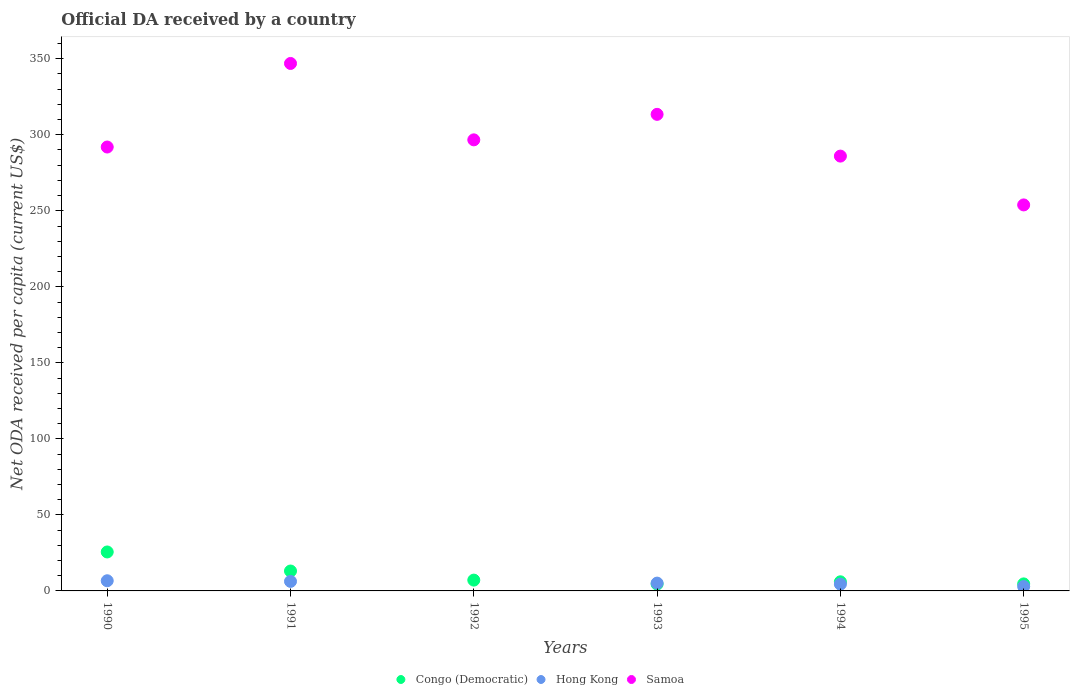Is the number of dotlines equal to the number of legend labels?
Offer a terse response. No. What is the ODA received in in Hong Kong in 1995?
Ensure brevity in your answer.  2.88. Across all years, what is the maximum ODA received in in Congo (Democratic)?
Make the answer very short. 25.62. Across all years, what is the minimum ODA received in in Congo (Democratic)?
Give a very brief answer. 4.52. What is the total ODA received in in Hong Kong in the graph?
Provide a short and direct response. 25.42. What is the difference between the ODA received in in Congo (Democratic) in 1990 and that in 1993?
Offer a terse response. 21.1. What is the difference between the ODA received in in Congo (Democratic) in 1991 and the ODA received in in Hong Kong in 1995?
Your answer should be very brief. 10.21. What is the average ODA received in in Samoa per year?
Provide a succinct answer. 298.14. In the year 1990, what is the difference between the ODA received in in Congo (Democratic) and ODA received in in Samoa?
Offer a terse response. -266.34. In how many years, is the ODA received in in Samoa greater than 200 US$?
Your answer should be very brief. 6. What is the ratio of the ODA received in in Congo (Democratic) in 1990 to that in 1994?
Provide a short and direct response. 4.27. Is the difference between the ODA received in in Congo (Democratic) in 1992 and 1994 greater than the difference between the ODA received in in Samoa in 1992 and 1994?
Offer a very short reply. No. What is the difference between the highest and the second highest ODA received in in Congo (Democratic)?
Provide a succinct answer. 12.53. What is the difference between the highest and the lowest ODA received in in Congo (Democratic)?
Provide a short and direct response. 21.1. Is the sum of the ODA received in in Samoa in 1992 and 1993 greater than the maximum ODA received in in Hong Kong across all years?
Your response must be concise. Yes. Does the ODA received in in Congo (Democratic) monotonically increase over the years?
Your response must be concise. No. Is the ODA received in in Congo (Democratic) strictly less than the ODA received in in Samoa over the years?
Offer a very short reply. Yes. How many dotlines are there?
Give a very brief answer. 3. What is the difference between two consecutive major ticks on the Y-axis?
Your answer should be compact. 50. Are the values on the major ticks of Y-axis written in scientific E-notation?
Give a very brief answer. No. Does the graph contain any zero values?
Provide a short and direct response. Yes. What is the title of the graph?
Ensure brevity in your answer.  Official DA received by a country. What is the label or title of the X-axis?
Provide a succinct answer. Years. What is the label or title of the Y-axis?
Your answer should be very brief. Net ODA received per capita (current US$). What is the Net ODA received per capita (current US$) of Congo (Democratic) in 1990?
Your answer should be compact. 25.62. What is the Net ODA received per capita (current US$) of Hong Kong in 1990?
Offer a terse response. 6.69. What is the Net ODA received per capita (current US$) of Samoa in 1990?
Offer a terse response. 291.96. What is the Net ODA received per capita (current US$) of Congo (Democratic) in 1991?
Your answer should be compact. 13.09. What is the Net ODA received per capita (current US$) in Hong Kong in 1991?
Offer a terse response. 6.27. What is the Net ODA received per capita (current US$) of Samoa in 1991?
Provide a succinct answer. 346.92. What is the Net ODA received per capita (current US$) in Congo (Democratic) in 1992?
Ensure brevity in your answer.  7.11. What is the Net ODA received per capita (current US$) of Samoa in 1992?
Provide a succinct answer. 296.68. What is the Net ODA received per capita (current US$) of Congo (Democratic) in 1993?
Provide a short and direct response. 4.52. What is the Net ODA received per capita (current US$) of Hong Kong in 1993?
Ensure brevity in your answer.  5.13. What is the Net ODA received per capita (current US$) of Samoa in 1993?
Offer a very short reply. 313.45. What is the Net ODA received per capita (current US$) of Congo (Democratic) in 1994?
Make the answer very short. 6. What is the Net ODA received per capita (current US$) of Hong Kong in 1994?
Offer a terse response. 4.45. What is the Net ODA received per capita (current US$) of Samoa in 1994?
Make the answer very short. 285.98. What is the Net ODA received per capita (current US$) in Congo (Democratic) in 1995?
Your answer should be very brief. 4.62. What is the Net ODA received per capita (current US$) of Hong Kong in 1995?
Provide a succinct answer. 2.88. What is the Net ODA received per capita (current US$) of Samoa in 1995?
Your response must be concise. 253.88. Across all years, what is the maximum Net ODA received per capita (current US$) of Congo (Democratic)?
Keep it short and to the point. 25.62. Across all years, what is the maximum Net ODA received per capita (current US$) of Hong Kong?
Give a very brief answer. 6.69. Across all years, what is the maximum Net ODA received per capita (current US$) of Samoa?
Your response must be concise. 346.92. Across all years, what is the minimum Net ODA received per capita (current US$) of Congo (Democratic)?
Your answer should be compact. 4.52. Across all years, what is the minimum Net ODA received per capita (current US$) of Hong Kong?
Keep it short and to the point. 0. Across all years, what is the minimum Net ODA received per capita (current US$) in Samoa?
Your answer should be compact. 253.88. What is the total Net ODA received per capita (current US$) in Congo (Democratic) in the graph?
Provide a succinct answer. 60.96. What is the total Net ODA received per capita (current US$) of Hong Kong in the graph?
Your answer should be compact. 25.42. What is the total Net ODA received per capita (current US$) in Samoa in the graph?
Provide a succinct answer. 1788.86. What is the difference between the Net ODA received per capita (current US$) in Congo (Democratic) in 1990 and that in 1991?
Keep it short and to the point. 12.53. What is the difference between the Net ODA received per capita (current US$) in Hong Kong in 1990 and that in 1991?
Offer a terse response. 0.42. What is the difference between the Net ODA received per capita (current US$) in Samoa in 1990 and that in 1991?
Offer a very short reply. -54.96. What is the difference between the Net ODA received per capita (current US$) in Congo (Democratic) in 1990 and that in 1992?
Provide a succinct answer. 18.51. What is the difference between the Net ODA received per capita (current US$) of Samoa in 1990 and that in 1992?
Provide a succinct answer. -4.72. What is the difference between the Net ODA received per capita (current US$) in Congo (Democratic) in 1990 and that in 1993?
Keep it short and to the point. 21.1. What is the difference between the Net ODA received per capita (current US$) in Hong Kong in 1990 and that in 1993?
Provide a short and direct response. 1.56. What is the difference between the Net ODA received per capita (current US$) in Samoa in 1990 and that in 1993?
Keep it short and to the point. -21.49. What is the difference between the Net ODA received per capita (current US$) of Congo (Democratic) in 1990 and that in 1994?
Keep it short and to the point. 19.62. What is the difference between the Net ODA received per capita (current US$) in Hong Kong in 1990 and that in 1994?
Provide a short and direct response. 2.24. What is the difference between the Net ODA received per capita (current US$) of Samoa in 1990 and that in 1994?
Ensure brevity in your answer.  5.98. What is the difference between the Net ODA received per capita (current US$) in Congo (Democratic) in 1990 and that in 1995?
Ensure brevity in your answer.  21. What is the difference between the Net ODA received per capita (current US$) of Hong Kong in 1990 and that in 1995?
Make the answer very short. 3.81. What is the difference between the Net ODA received per capita (current US$) in Samoa in 1990 and that in 1995?
Provide a short and direct response. 38.08. What is the difference between the Net ODA received per capita (current US$) of Congo (Democratic) in 1991 and that in 1992?
Ensure brevity in your answer.  5.98. What is the difference between the Net ODA received per capita (current US$) of Samoa in 1991 and that in 1992?
Ensure brevity in your answer.  50.24. What is the difference between the Net ODA received per capita (current US$) in Congo (Democratic) in 1991 and that in 1993?
Give a very brief answer. 8.57. What is the difference between the Net ODA received per capita (current US$) of Hong Kong in 1991 and that in 1993?
Provide a short and direct response. 1.14. What is the difference between the Net ODA received per capita (current US$) in Samoa in 1991 and that in 1993?
Offer a terse response. 33.47. What is the difference between the Net ODA received per capita (current US$) of Congo (Democratic) in 1991 and that in 1994?
Offer a terse response. 7.09. What is the difference between the Net ODA received per capita (current US$) in Hong Kong in 1991 and that in 1994?
Keep it short and to the point. 1.82. What is the difference between the Net ODA received per capita (current US$) of Samoa in 1991 and that in 1994?
Your answer should be compact. 60.94. What is the difference between the Net ODA received per capita (current US$) in Congo (Democratic) in 1991 and that in 1995?
Your response must be concise. 8.47. What is the difference between the Net ODA received per capita (current US$) in Hong Kong in 1991 and that in 1995?
Provide a succinct answer. 3.39. What is the difference between the Net ODA received per capita (current US$) in Samoa in 1991 and that in 1995?
Provide a short and direct response. 93.04. What is the difference between the Net ODA received per capita (current US$) of Congo (Democratic) in 1992 and that in 1993?
Provide a short and direct response. 2.58. What is the difference between the Net ODA received per capita (current US$) in Samoa in 1992 and that in 1993?
Make the answer very short. -16.77. What is the difference between the Net ODA received per capita (current US$) of Congo (Democratic) in 1992 and that in 1994?
Your response must be concise. 1.11. What is the difference between the Net ODA received per capita (current US$) in Samoa in 1992 and that in 1994?
Keep it short and to the point. 10.69. What is the difference between the Net ODA received per capita (current US$) of Congo (Democratic) in 1992 and that in 1995?
Make the answer very short. 2.49. What is the difference between the Net ODA received per capita (current US$) of Samoa in 1992 and that in 1995?
Ensure brevity in your answer.  42.79. What is the difference between the Net ODA received per capita (current US$) of Congo (Democratic) in 1993 and that in 1994?
Ensure brevity in your answer.  -1.48. What is the difference between the Net ODA received per capita (current US$) of Hong Kong in 1993 and that in 1994?
Make the answer very short. 0.68. What is the difference between the Net ODA received per capita (current US$) in Samoa in 1993 and that in 1994?
Offer a terse response. 27.46. What is the difference between the Net ODA received per capita (current US$) of Congo (Democratic) in 1993 and that in 1995?
Your answer should be compact. -0.09. What is the difference between the Net ODA received per capita (current US$) of Hong Kong in 1993 and that in 1995?
Offer a terse response. 2.25. What is the difference between the Net ODA received per capita (current US$) in Samoa in 1993 and that in 1995?
Provide a short and direct response. 59.56. What is the difference between the Net ODA received per capita (current US$) of Congo (Democratic) in 1994 and that in 1995?
Give a very brief answer. 1.38. What is the difference between the Net ODA received per capita (current US$) in Hong Kong in 1994 and that in 1995?
Offer a very short reply. 1.57. What is the difference between the Net ODA received per capita (current US$) of Samoa in 1994 and that in 1995?
Offer a very short reply. 32.1. What is the difference between the Net ODA received per capita (current US$) of Congo (Democratic) in 1990 and the Net ODA received per capita (current US$) of Hong Kong in 1991?
Make the answer very short. 19.35. What is the difference between the Net ODA received per capita (current US$) in Congo (Democratic) in 1990 and the Net ODA received per capita (current US$) in Samoa in 1991?
Keep it short and to the point. -321.3. What is the difference between the Net ODA received per capita (current US$) of Hong Kong in 1990 and the Net ODA received per capita (current US$) of Samoa in 1991?
Offer a very short reply. -340.23. What is the difference between the Net ODA received per capita (current US$) of Congo (Democratic) in 1990 and the Net ODA received per capita (current US$) of Samoa in 1992?
Your response must be concise. -271.05. What is the difference between the Net ODA received per capita (current US$) of Hong Kong in 1990 and the Net ODA received per capita (current US$) of Samoa in 1992?
Provide a succinct answer. -289.99. What is the difference between the Net ODA received per capita (current US$) of Congo (Democratic) in 1990 and the Net ODA received per capita (current US$) of Hong Kong in 1993?
Your answer should be very brief. 20.49. What is the difference between the Net ODA received per capita (current US$) in Congo (Democratic) in 1990 and the Net ODA received per capita (current US$) in Samoa in 1993?
Make the answer very short. -287.82. What is the difference between the Net ODA received per capita (current US$) of Hong Kong in 1990 and the Net ODA received per capita (current US$) of Samoa in 1993?
Offer a very short reply. -306.76. What is the difference between the Net ODA received per capita (current US$) in Congo (Democratic) in 1990 and the Net ODA received per capita (current US$) in Hong Kong in 1994?
Your response must be concise. 21.17. What is the difference between the Net ODA received per capita (current US$) of Congo (Democratic) in 1990 and the Net ODA received per capita (current US$) of Samoa in 1994?
Offer a very short reply. -260.36. What is the difference between the Net ODA received per capita (current US$) in Hong Kong in 1990 and the Net ODA received per capita (current US$) in Samoa in 1994?
Provide a succinct answer. -279.29. What is the difference between the Net ODA received per capita (current US$) in Congo (Democratic) in 1990 and the Net ODA received per capita (current US$) in Hong Kong in 1995?
Keep it short and to the point. 22.74. What is the difference between the Net ODA received per capita (current US$) of Congo (Democratic) in 1990 and the Net ODA received per capita (current US$) of Samoa in 1995?
Ensure brevity in your answer.  -228.26. What is the difference between the Net ODA received per capita (current US$) in Hong Kong in 1990 and the Net ODA received per capita (current US$) in Samoa in 1995?
Your response must be concise. -247.19. What is the difference between the Net ODA received per capita (current US$) of Congo (Democratic) in 1991 and the Net ODA received per capita (current US$) of Samoa in 1992?
Keep it short and to the point. -283.59. What is the difference between the Net ODA received per capita (current US$) of Hong Kong in 1991 and the Net ODA received per capita (current US$) of Samoa in 1992?
Make the answer very short. -290.4. What is the difference between the Net ODA received per capita (current US$) in Congo (Democratic) in 1991 and the Net ODA received per capita (current US$) in Hong Kong in 1993?
Keep it short and to the point. 7.96. What is the difference between the Net ODA received per capita (current US$) in Congo (Democratic) in 1991 and the Net ODA received per capita (current US$) in Samoa in 1993?
Provide a short and direct response. -300.36. What is the difference between the Net ODA received per capita (current US$) in Hong Kong in 1991 and the Net ODA received per capita (current US$) in Samoa in 1993?
Make the answer very short. -307.17. What is the difference between the Net ODA received per capita (current US$) of Congo (Democratic) in 1991 and the Net ODA received per capita (current US$) of Hong Kong in 1994?
Make the answer very short. 8.64. What is the difference between the Net ODA received per capita (current US$) in Congo (Democratic) in 1991 and the Net ODA received per capita (current US$) in Samoa in 1994?
Your response must be concise. -272.89. What is the difference between the Net ODA received per capita (current US$) in Hong Kong in 1991 and the Net ODA received per capita (current US$) in Samoa in 1994?
Your response must be concise. -279.71. What is the difference between the Net ODA received per capita (current US$) of Congo (Democratic) in 1991 and the Net ODA received per capita (current US$) of Hong Kong in 1995?
Make the answer very short. 10.21. What is the difference between the Net ODA received per capita (current US$) in Congo (Democratic) in 1991 and the Net ODA received per capita (current US$) in Samoa in 1995?
Keep it short and to the point. -240.79. What is the difference between the Net ODA received per capita (current US$) of Hong Kong in 1991 and the Net ODA received per capita (current US$) of Samoa in 1995?
Your answer should be very brief. -247.61. What is the difference between the Net ODA received per capita (current US$) in Congo (Democratic) in 1992 and the Net ODA received per capita (current US$) in Hong Kong in 1993?
Offer a very short reply. 1.98. What is the difference between the Net ODA received per capita (current US$) of Congo (Democratic) in 1992 and the Net ODA received per capita (current US$) of Samoa in 1993?
Give a very brief answer. -306.34. What is the difference between the Net ODA received per capita (current US$) of Congo (Democratic) in 1992 and the Net ODA received per capita (current US$) of Hong Kong in 1994?
Offer a terse response. 2.65. What is the difference between the Net ODA received per capita (current US$) of Congo (Democratic) in 1992 and the Net ODA received per capita (current US$) of Samoa in 1994?
Provide a succinct answer. -278.88. What is the difference between the Net ODA received per capita (current US$) in Congo (Democratic) in 1992 and the Net ODA received per capita (current US$) in Hong Kong in 1995?
Make the answer very short. 4.23. What is the difference between the Net ODA received per capita (current US$) in Congo (Democratic) in 1992 and the Net ODA received per capita (current US$) in Samoa in 1995?
Keep it short and to the point. -246.77. What is the difference between the Net ODA received per capita (current US$) in Congo (Democratic) in 1993 and the Net ODA received per capita (current US$) in Hong Kong in 1994?
Offer a terse response. 0.07. What is the difference between the Net ODA received per capita (current US$) in Congo (Democratic) in 1993 and the Net ODA received per capita (current US$) in Samoa in 1994?
Your response must be concise. -281.46. What is the difference between the Net ODA received per capita (current US$) of Hong Kong in 1993 and the Net ODA received per capita (current US$) of Samoa in 1994?
Ensure brevity in your answer.  -280.85. What is the difference between the Net ODA received per capita (current US$) of Congo (Democratic) in 1993 and the Net ODA received per capita (current US$) of Hong Kong in 1995?
Offer a terse response. 1.64. What is the difference between the Net ODA received per capita (current US$) of Congo (Democratic) in 1993 and the Net ODA received per capita (current US$) of Samoa in 1995?
Offer a terse response. -249.36. What is the difference between the Net ODA received per capita (current US$) in Hong Kong in 1993 and the Net ODA received per capita (current US$) in Samoa in 1995?
Keep it short and to the point. -248.75. What is the difference between the Net ODA received per capita (current US$) in Congo (Democratic) in 1994 and the Net ODA received per capita (current US$) in Hong Kong in 1995?
Your answer should be very brief. 3.12. What is the difference between the Net ODA received per capita (current US$) of Congo (Democratic) in 1994 and the Net ODA received per capita (current US$) of Samoa in 1995?
Your answer should be compact. -247.88. What is the difference between the Net ODA received per capita (current US$) of Hong Kong in 1994 and the Net ODA received per capita (current US$) of Samoa in 1995?
Offer a very short reply. -249.43. What is the average Net ODA received per capita (current US$) of Congo (Democratic) per year?
Offer a very short reply. 10.16. What is the average Net ODA received per capita (current US$) of Hong Kong per year?
Your answer should be compact. 4.24. What is the average Net ODA received per capita (current US$) of Samoa per year?
Give a very brief answer. 298.14. In the year 1990, what is the difference between the Net ODA received per capita (current US$) in Congo (Democratic) and Net ODA received per capita (current US$) in Hong Kong?
Offer a terse response. 18.93. In the year 1990, what is the difference between the Net ODA received per capita (current US$) of Congo (Democratic) and Net ODA received per capita (current US$) of Samoa?
Give a very brief answer. -266.34. In the year 1990, what is the difference between the Net ODA received per capita (current US$) of Hong Kong and Net ODA received per capita (current US$) of Samoa?
Give a very brief answer. -285.27. In the year 1991, what is the difference between the Net ODA received per capita (current US$) of Congo (Democratic) and Net ODA received per capita (current US$) of Hong Kong?
Your response must be concise. 6.82. In the year 1991, what is the difference between the Net ODA received per capita (current US$) of Congo (Democratic) and Net ODA received per capita (current US$) of Samoa?
Provide a short and direct response. -333.83. In the year 1991, what is the difference between the Net ODA received per capita (current US$) in Hong Kong and Net ODA received per capita (current US$) in Samoa?
Offer a very short reply. -340.65. In the year 1992, what is the difference between the Net ODA received per capita (current US$) in Congo (Democratic) and Net ODA received per capita (current US$) in Samoa?
Give a very brief answer. -289.57. In the year 1993, what is the difference between the Net ODA received per capita (current US$) in Congo (Democratic) and Net ODA received per capita (current US$) in Hong Kong?
Make the answer very short. -0.61. In the year 1993, what is the difference between the Net ODA received per capita (current US$) of Congo (Democratic) and Net ODA received per capita (current US$) of Samoa?
Make the answer very short. -308.92. In the year 1993, what is the difference between the Net ODA received per capita (current US$) of Hong Kong and Net ODA received per capita (current US$) of Samoa?
Keep it short and to the point. -308.32. In the year 1994, what is the difference between the Net ODA received per capita (current US$) in Congo (Democratic) and Net ODA received per capita (current US$) in Hong Kong?
Ensure brevity in your answer.  1.55. In the year 1994, what is the difference between the Net ODA received per capita (current US$) in Congo (Democratic) and Net ODA received per capita (current US$) in Samoa?
Offer a very short reply. -279.98. In the year 1994, what is the difference between the Net ODA received per capita (current US$) of Hong Kong and Net ODA received per capita (current US$) of Samoa?
Your answer should be compact. -281.53. In the year 1995, what is the difference between the Net ODA received per capita (current US$) of Congo (Democratic) and Net ODA received per capita (current US$) of Hong Kong?
Offer a very short reply. 1.74. In the year 1995, what is the difference between the Net ODA received per capita (current US$) in Congo (Democratic) and Net ODA received per capita (current US$) in Samoa?
Your answer should be very brief. -249.26. In the year 1995, what is the difference between the Net ODA received per capita (current US$) in Hong Kong and Net ODA received per capita (current US$) in Samoa?
Keep it short and to the point. -251. What is the ratio of the Net ODA received per capita (current US$) of Congo (Democratic) in 1990 to that in 1991?
Your response must be concise. 1.96. What is the ratio of the Net ODA received per capita (current US$) of Hong Kong in 1990 to that in 1991?
Your response must be concise. 1.07. What is the ratio of the Net ODA received per capita (current US$) of Samoa in 1990 to that in 1991?
Make the answer very short. 0.84. What is the ratio of the Net ODA received per capita (current US$) in Congo (Democratic) in 1990 to that in 1992?
Make the answer very short. 3.61. What is the ratio of the Net ODA received per capita (current US$) of Samoa in 1990 to that in 1992?
Keep it short and to the point. 0.98. What is the ratio of the Net ODA received per capita (current US$) in Congo (Democratic) in 1990 to that in 1993?
Provide a short and direct response. 5.66. What is the ratio of the Net ODA received per capita (current US$) in Hong Kong in 1990 to that in 1993?
Give a very brief answer. 1.3. What is the ratio of the Net ODA received per capita (current US$) of Samoa in 1990 to that in 1993?
Ensure brevity in your answer.  0.93. What is the ratio of the Net ODA received per capita (current US$) in Congo (Democratic) in 1990 to that in 1994?
Give a very brief answer. 4.27. What is the ratio of the Net ODA received per capita (current US$) of Hong Kong in 1990 to that in 1994?
Your answer should be compact. 1.5. What is the ratio of the Net ODA received per capita (current US$) in Samoa in 1990 to that in 1994?
Provide a succinct answer. 1.02. What is the ratio of the Net ODA received per capita (current US$) in Congo (Democratic) in 1990 to that in 1995?
Give a very brief answer. 5.55. What is the ratio of the Net ODA received per capita (current US$) in Hong Kong in 1990 to that in 1995?
Provide a short and direct response. 2.32. What is the ratio of the Net ODA received per capita (current US$) in Samoa in 1990 to that in 1995?
Your response must be concise. 1.15. What is the ratio of the Net ODA received per capita (current US$) of Congo (Democratic) in 1991 to that in 1992?
Give a very brief answer. 1.84. What is the ratio of the Net ODA received per capita (current US$) of Samoa in 1991 to that in 1992?
Offer a terse response. 1.17. What is the ratio of the Net ODA received per capita (current US$) in Congo (Democratic) in 1991 to that in 1993?
Your answer should be compact. 2.89. What is the ratio of the Net ODA received per capita (current US$) of Hong Kong in 1991 to that in 1993?
Make the answer very short. 1.22. What is the ratio of the Net ODA received per capita (current US$) of Samoa in 1991 to that in 1993?
Ensure brevity in your answer.  1.11. What is the ratio of the Net ODA received per capita (current US$) in Congo (Democratic) in 1991 to that in 1994?
Give a very brief answer. 2.18. What is the ratio of the Net ODA received per capita (current US$) in Hong Kong in 1991 to that in 1994?
Offer a terse response. 1.41. What is the ratio of the Net ODA received per capita (current US$) of Samoa in 1991 to that in 1994?
Ensure brevity in your answer.  1.21. What is the ratio of the Net ODA received per capita (current US$) in Congo (Democratic) in 1991 to that in 1995?
Provide a succinct answer. 2.84. What is the ratio of the Net ODA received per capita (current US$) of Hong Kong in 1991 to that in 1995?
Provide a succinct answer. 2.18. What is the ratio of the Net ODA received per capita (current US$) of Samoa in 1991 to that in 1995?
Provide a succinct answer. 1.37. What is the ratio of the Net ODA received per capita (current US$) of Congo (Democratic) in 1992 to that in 1993?
Provide a short and direct response. 1.57. What is the ratio of the Net ODA received per capita (current US$) of Samoa in 1992 to that in 1993?
Offer a terse response. 0.95. What is the ratio of the Net ODA received per capita (current US$) in Congo (Democratic) in 1992 to that in 1994?
Offer a terse response. 1.18. What is the ratio of the Net ODA received per capita (current US$) in Samoa in 1992 to that in 1994?
Offer a terse response. 1.04. What is the ratio of the Net ODA received per capita (current US$) in Congo (Democratic) in 1992 to that in 1995?
Make the answer very short. 1.54. What is the ratio of the Net ODA received per capita (current US$) in Samoa in 1992 to that in 1995?
Provide a succinct answer. 1.17. What is the ratio of the Net ODA received per capita (current US$) of Congo (Democratic) in 1993 to that in 1994?
Keep it short and to the point. 0.75. What is the ratio of the Net ODA received per capita (current US$) in Hong Kong in 1993 to that in 1994?
Your response must be concise. 1.15. What is the ratio of the Net ODA received per capita (current US$) of Samoa in 1993 to that in 1994?
Offer a terse response. 1.1. What is the ratio of the Net ODA received per capita (current US$) of Congo (Democratic) in 1993 to that in 1995?
Ensure brevity in your answer.  0.98. What is the ratio of the Net ODA received per capita (current US$) in Hong Kong in 1993 to that in 1995?
Your response must be concise. 1.78. What is the ratio of the Net ODA received per capita (current US$) in Samoa in 1993 to that in 1995?
Ensure brevity in your answer.  1.23. What is the ratio of the Net ODA received per capita (current US$) of Congo (Democratic) in 1994 to that in 1995?
Provide a short and direct response. 1.3. What is the ratio of the Net ODA received per capita (current US$) of Hong Kong in 1994 to that in 1995?
Provide a short and direct response. 1.55. What is the ratio of the Net ODA received per capita (current US$) of Samoa in 1994 to that in 1995?
Ensure brevity in your answer.  1.13. What is the difference between the highest and the second highest Net ODA received per capita (current US$) of Congo (Democratic)?
Provide a short and direct response. 12.53. What is the difference between the highest and the second highest Net ODA received per capita (current US$) in Hong Kong?
Provide a succinct answer. 0.42. What is the difference between the highest and the second highest Net ODA received per capita (current US$) of Samoa?
Offer a terse response. 33.47. What is the difference between the highest and the lowest Net ODA received per capita (current US$) of Congo (Democratic)?
Offer a very short reply. 21.1. What is the difference between the highest and the lowest Net ODA received per capita (current US$) in Hong Kong?
Make the answer very short. 6.69. What is the difference between the highest and the lowest Net ODA received per capita (current US$) in Samoa?
Offer a terse response. 93.04. 